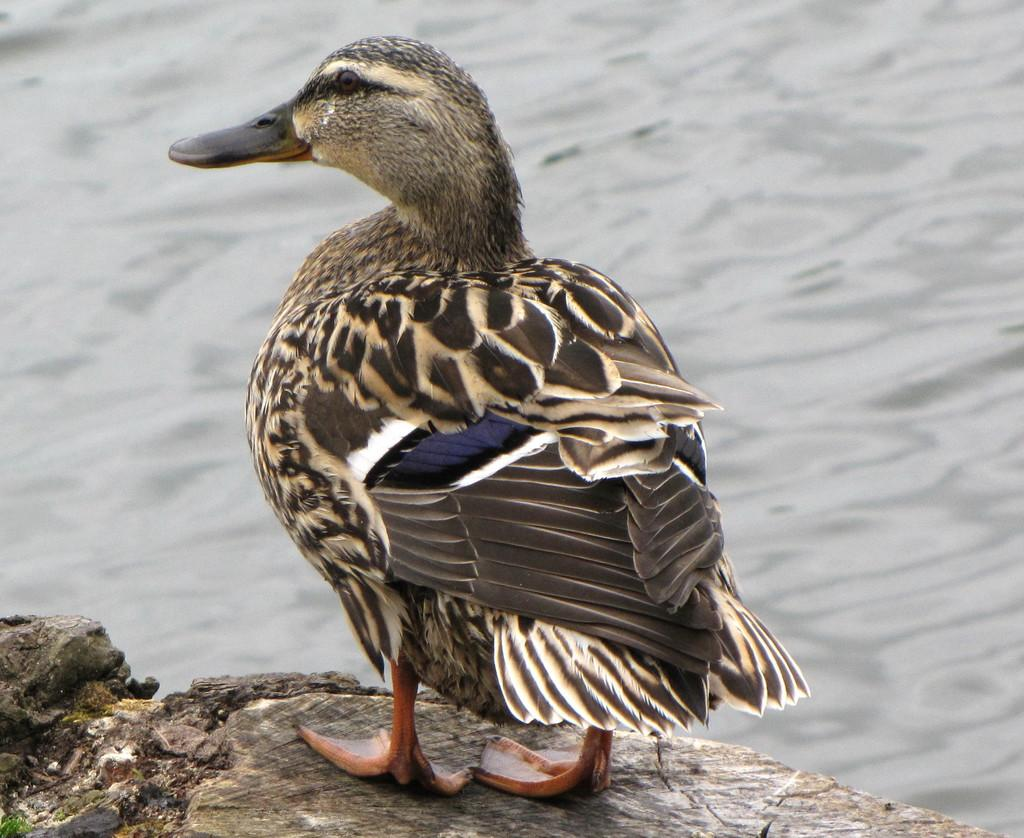What type of animal is in the image? There is a bird in the image. Can you describe the bird's coloring? The bird has black and brown coloring. How is the image quality in the background? The image is slightly blurry in the background. What type of furniture can be seen in the image? There is no furniture present in the image; it features a bird with black and brown coloring. How deep is the hole in the image? There is no hole present in the image; it features a bird with black and brown coloring. 